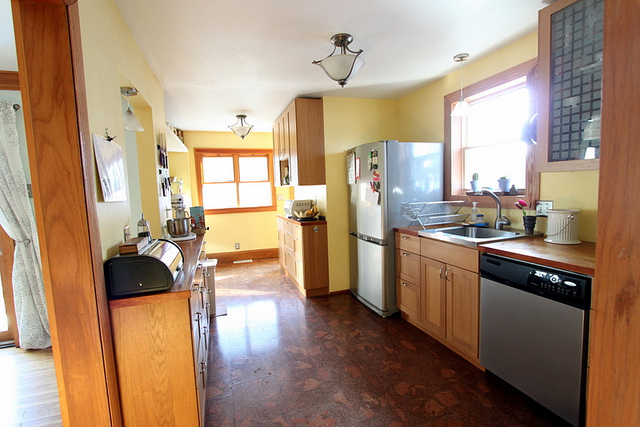Why was this picture taken? It's unclear exactly why this picture was taken without more context, but it might have been to showcase the kitchen's layout and design for real estate or remodeling purposes. 